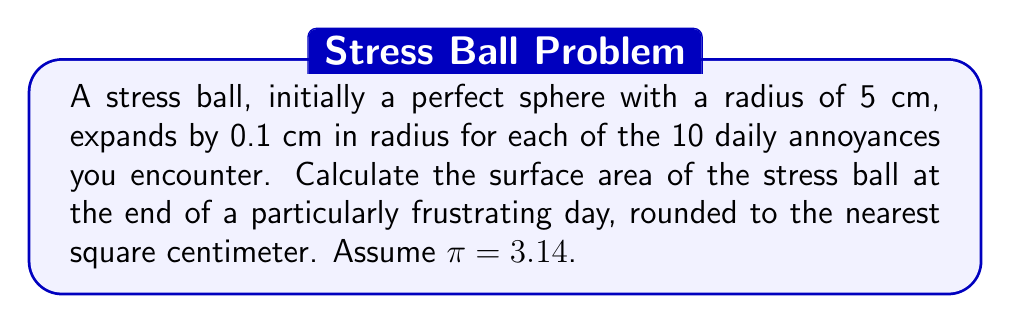Could you help me with this problem? Let's approach this step-by-step:

1) Initially, the radius is 5 cm.

2) The ball expands 0.1 cm for each of the 10 annoyances.
   Total expansion = $10 \times 0.1$ cm = 1 cm

3) Final radius = Initial radius + Total expansion
   $r = 5 + 1 = 6$ cm

4) The surface area of a sphere is given by the formula:
   $A = 4\pi r^2$

5) Substituting our values:
   $A = 4 \times 3.14 \times 6^2$

6) Calculate:
   $A = 4 \times 3.14 \times 36$
   $A = 452.16$ cm²

7) Rounding to the nearest square centimeter:
   $A \approx 452$ cm²
Answer: 452 cm² 